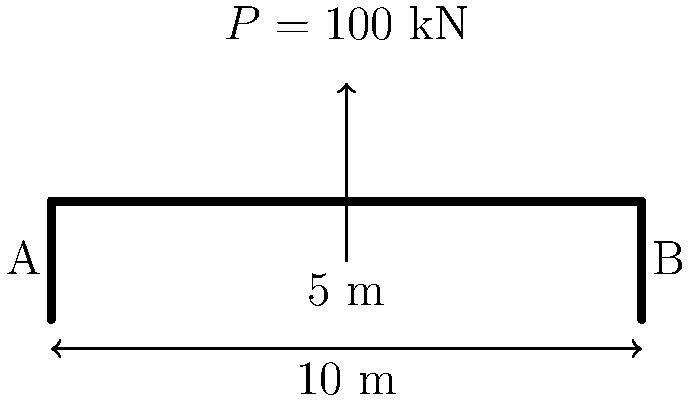A simple beam bridge spans 10 meters and carries a point load of 100 kN at its midpoint. Given that the bridge is made of steel with a yield strength of 250 MPa and a rectangular cross-section of 200 mm width and 400 mm depth, determine the maximum bending stress in the beam. Is the beam safe under this loading condition? To solve this problem, we'll follow these steps:

1) Calculate the maximum bending moment:
   For a simply supported beam with a point load at the center:
   $$M_{max} = \frac{PL}{4}$$
   Where $P$ is the point load and $L$ is the span length.
   $$M_{max} = \frac{100 \text{ kN} \times 10 \text{ m}}{4} = 250 \text{ kN·m}$$

2) Calculate the section modulus:
   For a rectangular section: $$S = \frac{bd^2}{6}$$
   Where $b$ is the width and $d$ is the depth.
   $$S = \frac{200 \text{ mm} \times (400 \text{ mm})^2}{6} = 5.33 \times 10^6 \text{ mm}^3$$

3) Calculate the maximum bending stress:
   $$\sigma_{max} = \frac{M_{max}}{S}$$
   $$\sigma_{max} = \frac{250 \text{ kN·m}}{5.33 \times 10^6 \text{ mm}^3} = 46.9 \text{ MPa}$$

4) Compare with yield strength:
   The maximum stress (46.9 MPa) is less than the yield strength (250 MPa).
   Safety factor = $\frac{250 \text{ MPa}}{46.9 \text{ MPa}} = 5.33$

Therefore, the beam is safe under this loading condition with a safety factor of 5.33.
Answer: Yes, the beam is safe. Maximum bending stress = 46.9 MPa < 250 MPa yield strength. 